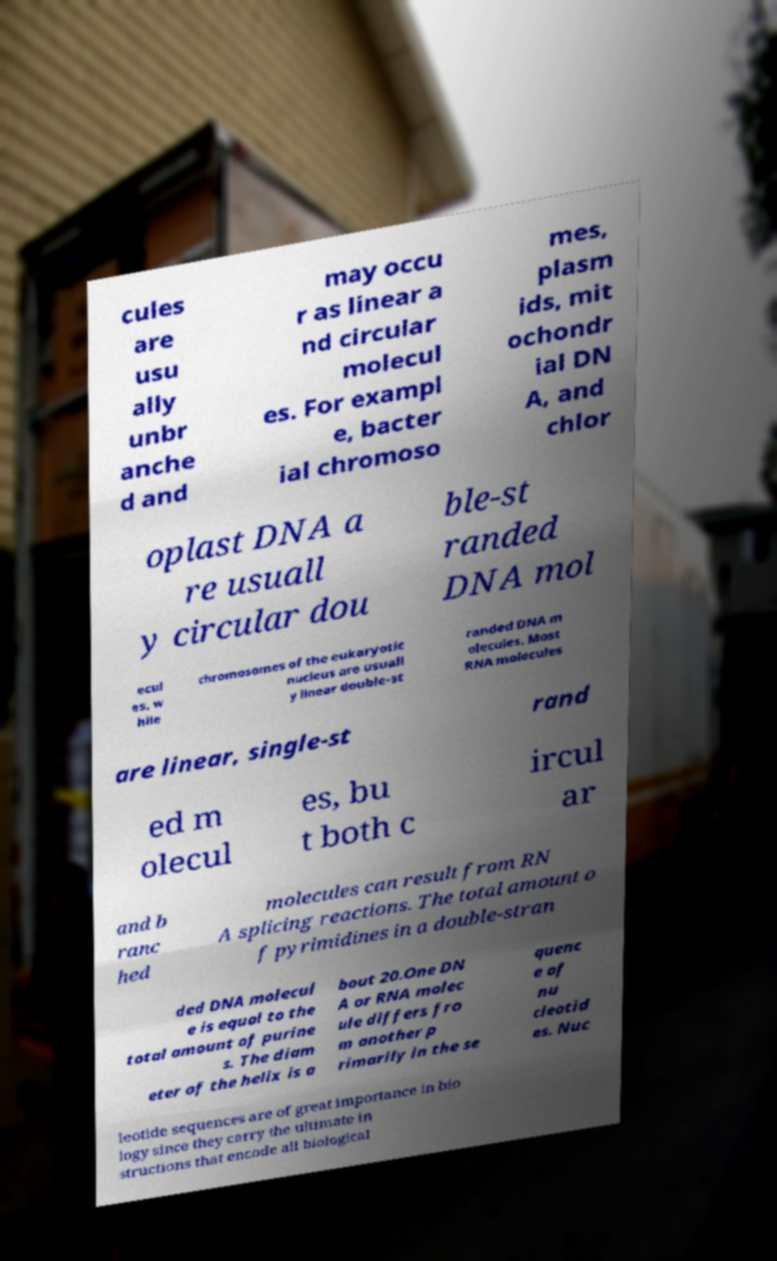There's text embedded in this image that I need extracted. Can you transcribe it verbatim? cules are usu ally unbr anche d and may occu r as linear a nd circular molecul es. For exampl e, bacter ial chromoso mes, plasm ids, mit ochondr ial DN A, and chlor oplast DNA a re usuall y circular dou ble-st randed DNA mol ecul es, w hile chromosomes of the eukaryotic nucleus are usuall y linear double-st randed DNA m olecules. Most RNA molecules are linear, single-st rand ed m olecul es, bu t both c ircul ar and b ranc hed molecules can result from RN A splicing reactions. The total amount o f pyrimidines in a double-stran ded DNA molecul e is equal to the total amount of purine s. The diam eter of the helix is a bout 20.One DN A or RNA molec ule differs fro m another p rimarily in the se quenc e of nu cleotid es. Nuc leotide sequences are of great importance in bio logy since they carry the ultimate in structions that encode all biological 